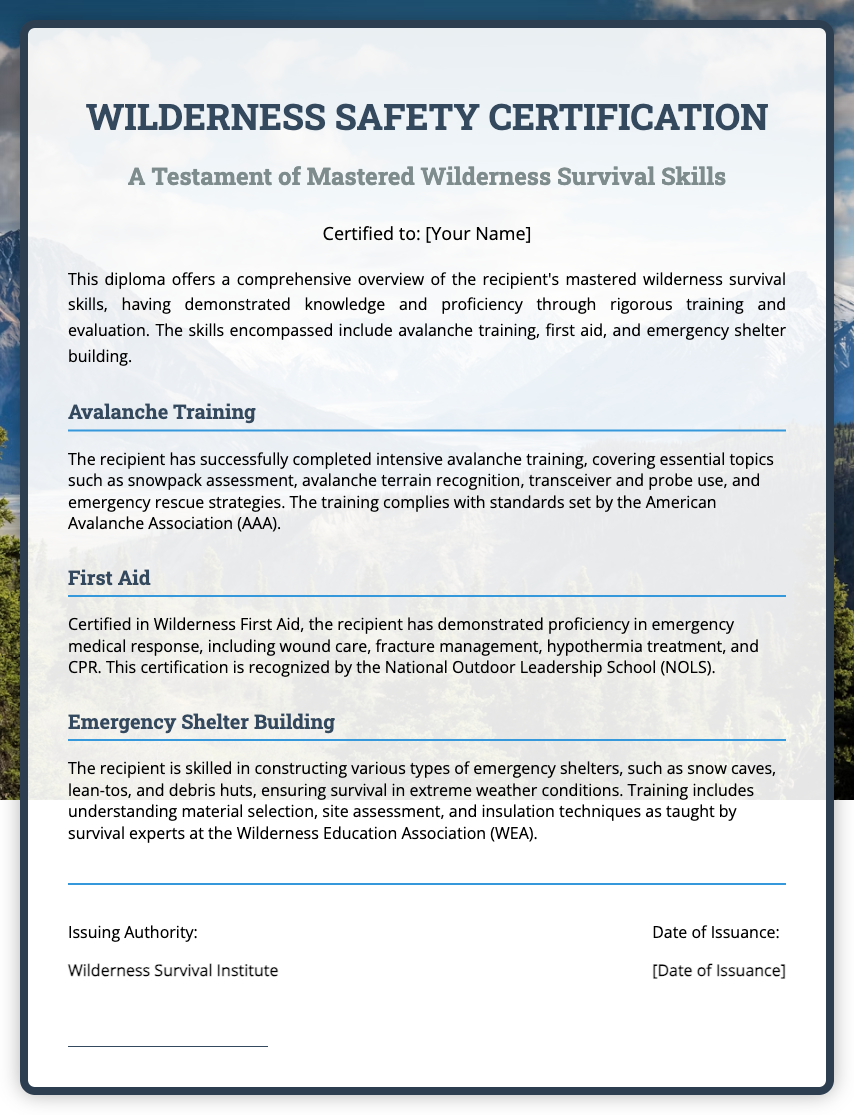What is the title of the certification? The title of the certification is prominently displayed at the top of the diploma.
Answer: Wilderness Safety Certification Who is the recipient of the certification? The recipient's name is indicated in the designated area of the diploma.
Answer: [Your Name] What organization issued this diploma? The issuing authority of the diploma is mentioned in the footer section.
Answer: Wilderness Survival Institute What date is listed for the issuance of the diploma? The date of issuance is indicated in the footer section next to the issuing authority.
Answer: [Date of Issuance] What skill does the section titled "Avalanche Training" focus on? The section titled "Avalanche Training" highlights specific topics on avalanche training that have been successfully completed.
Answer: Snowpack assessment What is one skill the recipient demonstrated proficiency in within "First Aid"? The "First Aid" section lists skills the recipient has mastered during their training.
Answer: CPR What type of emergency shelters can the recipient build according to the document? The "Emergency Shelter Building" section describes different types of shelters the recipient can construct.
Answer: Snow caves Which organization recognizes the Wilderness First Aid certification? The document states this certification is recognized by a specific organization.
Answer: National Outdoor Leadership School What does the background image of the diploma depict? The background image choice reflects the certificate's theme and context related to wilderness activities.
Answer: Mountains 